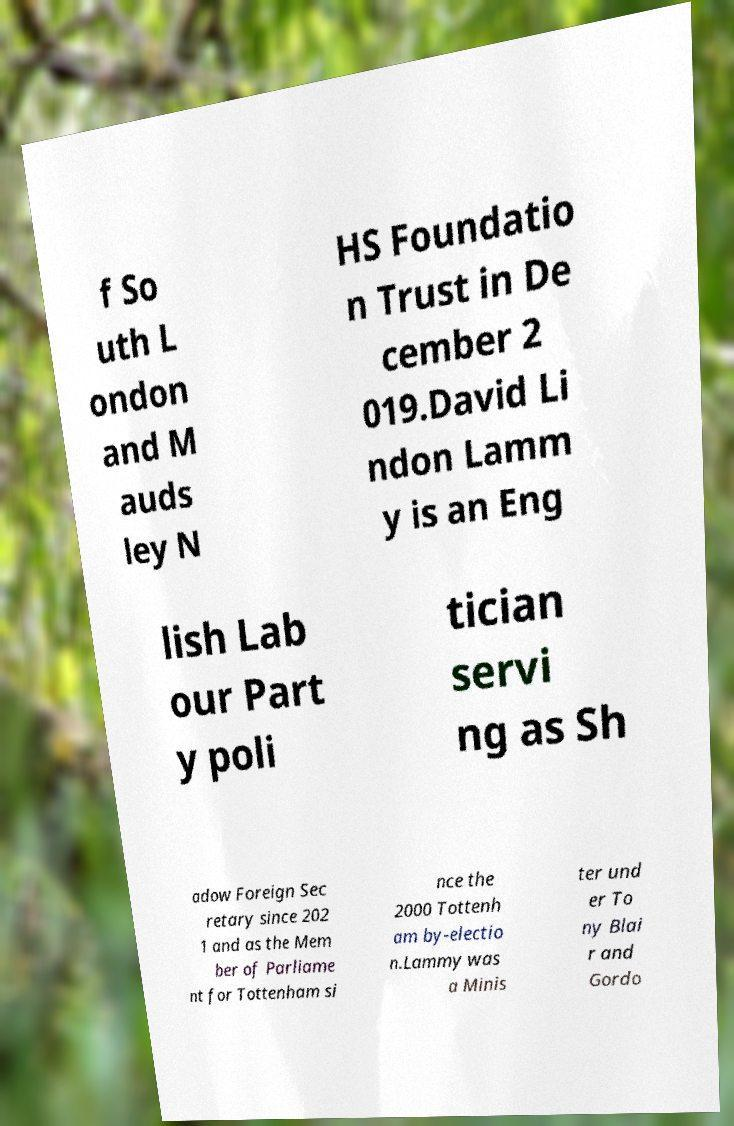Could you extract and type out the text from this image? f So uth L ondon and M auds ley N HS Foundatio n Trust in De cember 2 019.David Li ndon Lamm y is an Eng lish Lab our Part y poli tician servi ng as Sh adow Foreign Sec retary since 202 1 and as the Mem ber of Parliame nt for Tottenham si nce the 2000 Tottenh am by-electio n.Lammy was a Minis ter und er To ny Blai r and Gordo 